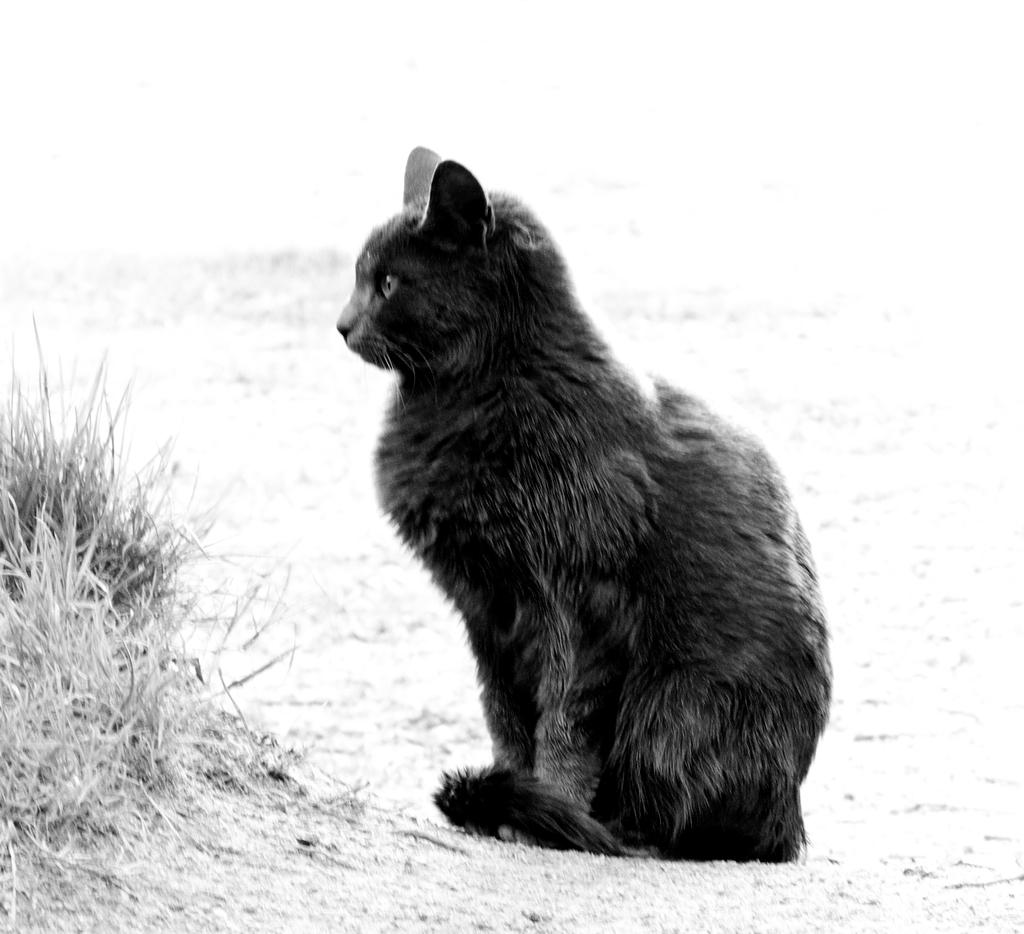What color is the grass in the image? The grass in the image is black in color. How is the grass in the image? The grass in the image is cut and dry. How many dolls are sitting on the bike in the image? There are no dolls or bikes present in the image; it features black grass that is cut and dry. 